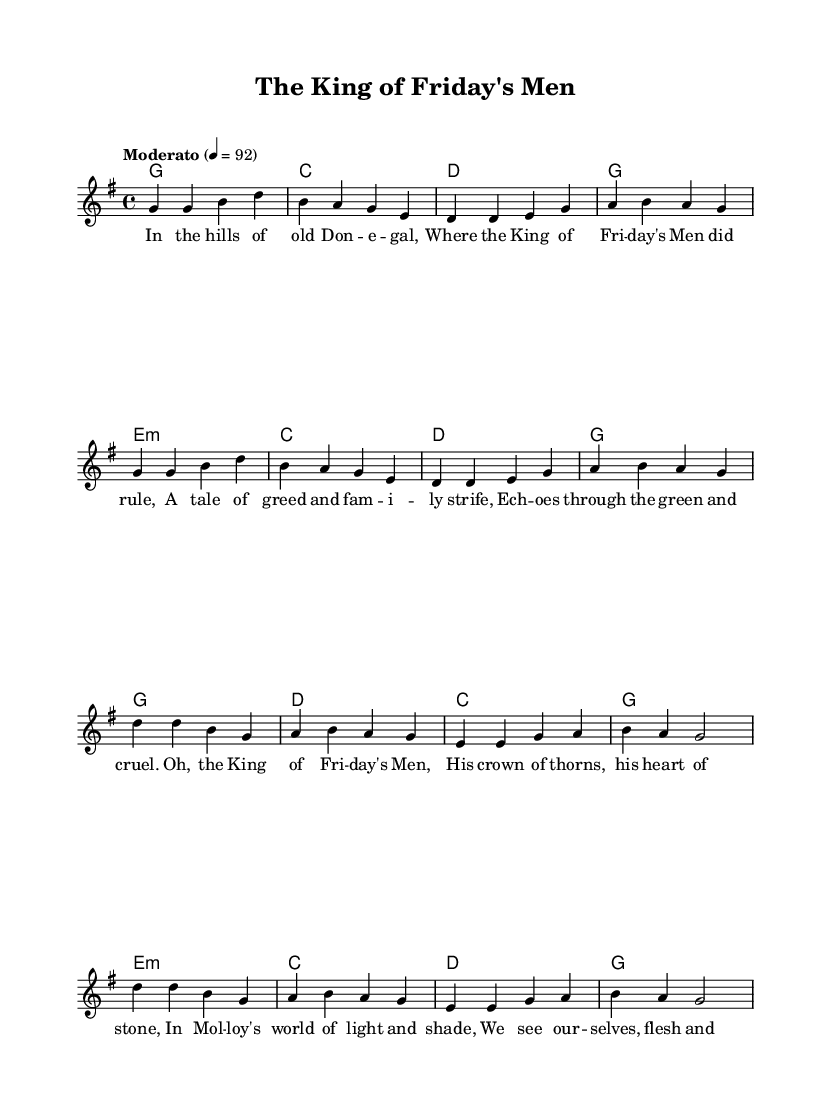What is the key signature of this music? The key signature is G major, which has one sharp (F#). This can be identified at the beginning of the score where the key signature is indicated.
Answer: G major What is the time signature of the piece? The time signature is 4/4, indicated at the beginning of the score. This means there are four beats per measure and each beat is a quarter note.
Answer: 4/4 What is the tempo marking of this piece? The tempo marking indicates "Moderato," which suggests a moderate speed. The metronome marking is given as 4 beats per minute equals 92.
Answer: Moderato How many measures are in the verse section? There are 8 measures in the verse section, which can be counted in the melody line where the music is notated.
Answer: 8 What does the chorus highlight in terms of thematic content? The chorus emphasizes themes of struggle and identity, referring to "the King of Friday's Men" and presenting a contrast with the earlier verse. This can be inferred from the lyrics and their emotional weight.
Answer: Themes of struggle and identity What are the primary chords used in the chorus? The primary chords used in the chorus are G, D, C, and E minor. These chords support the melody and provide harmonic structure, consistent with traditional country music.
Answer: G, D, C, E minor What lyrical theme is consistent with M.J. Molloy's works? The lyrical theme reflects elements of familial strife and personal conflict, which are frequent in Molloy's dramatic narratives. This connection can be drawn from the context and subject matter of both the lyrics and Molloy's plays.
Answer: Familial strife and personal conflict 